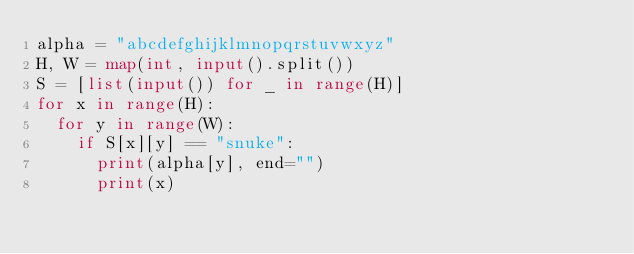<code> <loc_0><loc_0><loc_500><loc_500><_Python_>alpha = "abcdefghijklmnopqrstuvwxyz"
H, W = map(int, input().split())
S = [list(input()) for _ in range(H)]
for x in range(H):
  for y in range(W):
    if S[x][y] == "snuke":
      print(alpha[y], end="")
      print(x)</code> 